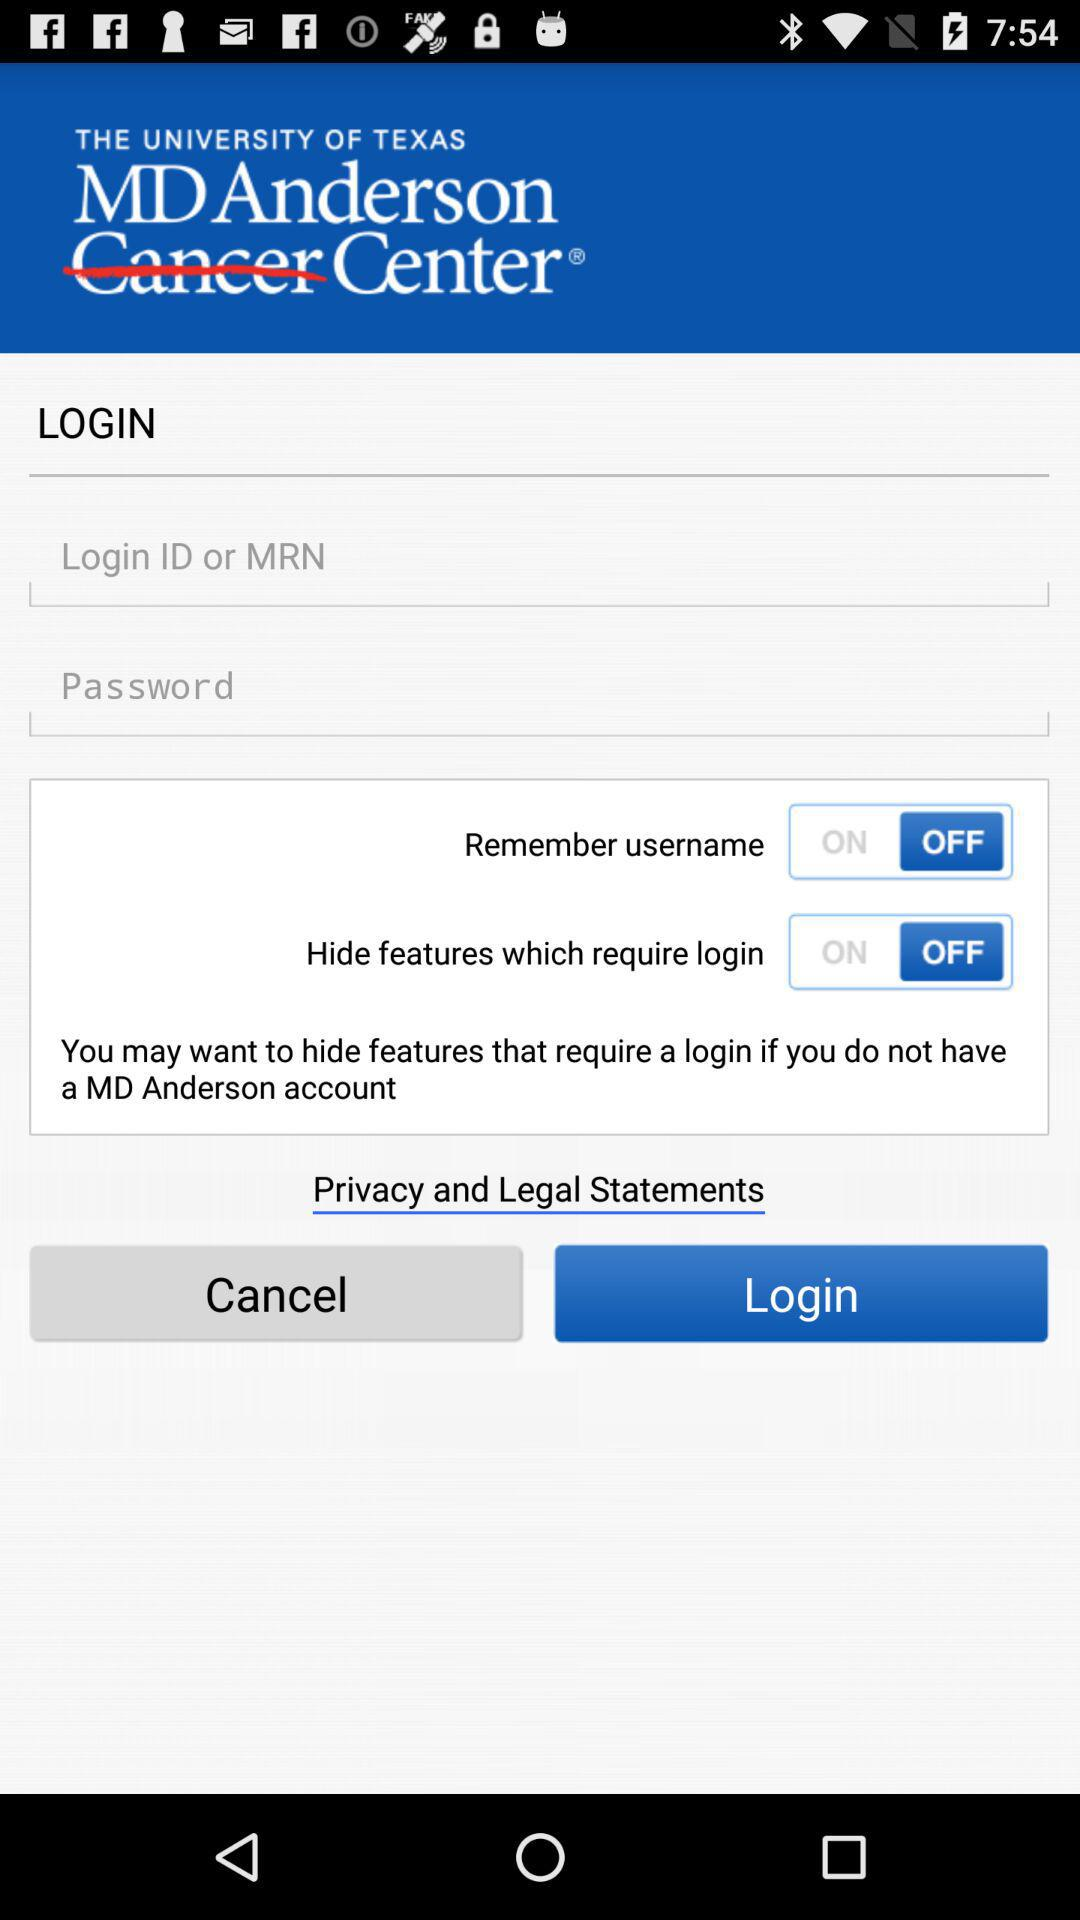What is the status of "Remember username"? The status is "off". 